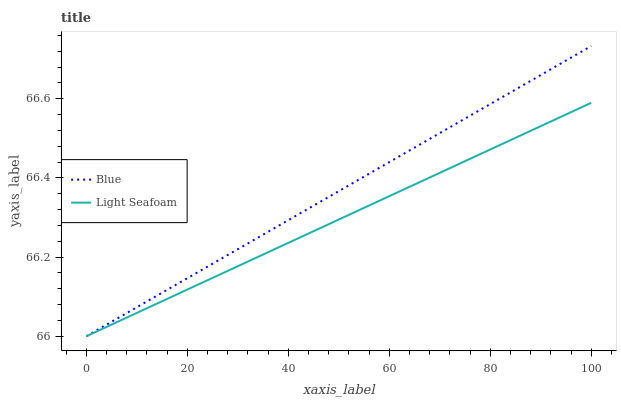Does Light Seafoam have the minimum area under the curve?
Answer yes or no. Yes. Does Blue have the maximum area under the curve?
Answer yes or no. Yes. Does Light Seafoam have the maximum area under the curve?
Answer yes or no. No. Is Light Seafoam the smoothest?
Answer yes or no. Yes. Is Blue the roughest?
Answer yes or no. Yes. Is Light Seafoam the roughest?
Answer yes or no. No. Does Blue have the highest value?
Answer yes or no. Yes. Does Light Seafoam have the highest value?
Answer yes or no. No. 